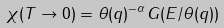<formula> <loc_0><loc_0><loc_500><loc_500>\chi ( T \rightarrow 0 ) = \theta ( { q } ) ^ { - \alpha } G ( E / \theta ( { q } ) )</formula> 